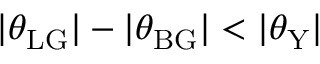Convert formula to latex. <formula><loc_0><loc_0><loc_500><loc_500>| \theta _ { L G } | - | \theta _ { B G } | < | \theta _ { Y } |</formula> 